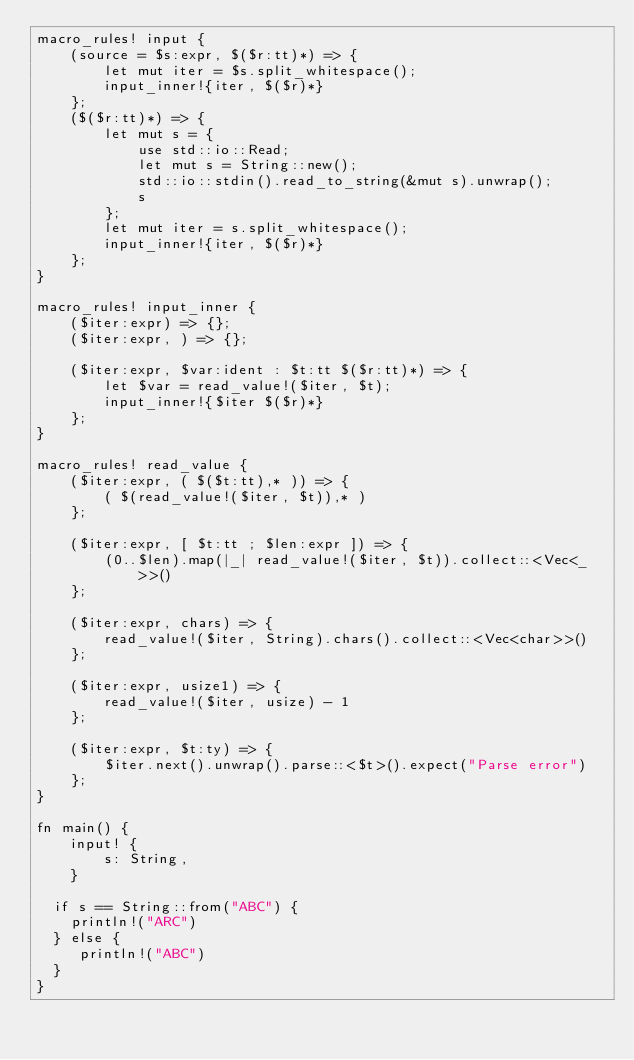<code> <loc_0><loc_0><loc_500><loc_500><_Rust_>macro_rules! input {
    (source = $s:expr, $($r:tt)*) => {
        let mut iter = $s.split_whitespace();
        input_inner!{iter, $($r)*}
    };
    ($($r:tt)*) => {
        let mut s = {
            use std::io::Read;
            let mut s = String::new();
            std::io::stdin().read_to_string(&mut s).unwrap();
            s
        };
        let mut iter = s.split_whitespace();
        input_inner!{iter, $($r)*}
    };
}

macro_rules! input_inner {
    ($iter:expr) => {};
    ($iter:expr, ) => {};

    ($iter:expr, $var:ident : $t:tt $($r:tt)*) => {
        let $var = read_value!($iter, $t);
        input_inner!{$iter $($r)*}
    };
}

macro_rules! read_value {
    ($iter:expr, ( $($t:tt),* )) => {
        ( $(read_value!($iter, $t)),* )
    };

    ($iter:expr, [ $t:tt ; $len:expr ]) => {
        (0..$len).map(|_| read_value!($iter, $t)).collect::<Vec<_>>()
    };

    ($iter:expr, chars) => {
        read_value!($iter, String).chars().collect::<Vec<char>>()
    };

    ($iter:expr, usize1) => {
        read_value!($iter, usize) - 1
    };

    ($iter:expr, $t:ty) => {
        $iter.next().unwrap().parse::<$t>().expect("Parse error")
    };
}

fn main() {
    input! {
        s: String,
    }
	
  if s == String::from("ABC") {
    println!("ARC")
  } else {
     println!("ABC")
  }
}
</code> 